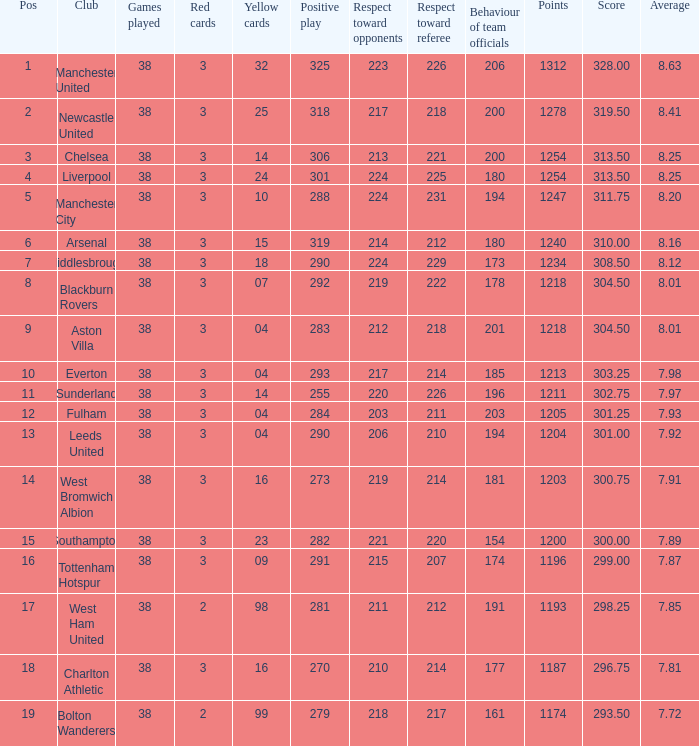Parse the table in full. {'header': ['Pos', 'Club', 'Games played', 'Red cards', 'Yellow cards', 'Positive play', 'Respect toward opponents', 'Respect toward referee', 'Behaviour of team officials', 'Points', 'Score', 'Average'], 'rows': [['1', 'Manchester United', '38', '3', '32', '325', '223', '226', '206', '1312', '328.00', '8.63'], ['2', 'Newcastle United', '38', '3', '25', '318', '217', '218', '200', '1278', '319.50', '8.41'], ['3', 'Chelsea', '38', '3', '14', '306', '213', '221', '200', '1254', '313.50', '8.25'], ['4', 'Liverpool', '38', '3', '24', '301', '224', '225', '180', '1254', '313.50', '8.25'], ['5', 'Manchester City', '38', '3', '10', '288', '224', '231', '194', '1247', '311.75', '8.20'], ['6', 'Arsenal', '38', '3', '15', '319', '214', '212', '180', '1240', '310.00', '8.16'], ['7', 'Middlesbrough', '38', '3', '18', '290', '224', '229', '173', '1234', '308.50', '8.12'], ['8', 'Blackburn Rovers', '38', '3', '07', '292', '219', '222', '178', '1218', '304.50', '8.01'], ['9', 'Aston Villa', '38', '3', '04', '283', '212', '218', '201', '1218', '304.50', '8.01'], ['10', 'Everton', '38', '3', '04', '293', '217', '214', '185', '1213', '303.25', '7.98'], ['11', 'Sunderland', '38', '3', '14', '255', '220', '226', '196', '1211', '302.75', '7.97'], ['12', 'Fulham', '38', '3', '04', '284', '203', '211', '203', '1205', '301.25', '7.93'], ['13', 'Leeds United', '38', '3', '04', '290', '206', '210', '194', '1204', '301.00', '7.92'], ['14', 'West Bromwich Albion', '38', '3', '16', '273', '219', '214', '181', '1203', '300.75', '7.91'], ['15', 'Southampton', '38', '3', '23', '282', '221', '220', '154', '1200', '300.00', '7.89'], ['16', 'Tottenham Hotspur', '38', '3', '09', '291', '215', '207', '174', '1196', '299.00', '7.87'], ['17', 'West Ham United', '38', '2', '98', '281', '211', '212', '191', '1193', '298.25', '7.85'], ['18', 'Charlton Athletic', '38', '3', '16', '270', '210', '214', '177', '1187', '296.75', '7.81'], ['19', 'Bolton Wanderers', '38', '2', '99', '279', '218', '217', '161', '1174', '293.50', '7.72']]} Name the most pos for west bromwich albion club 14.0. 